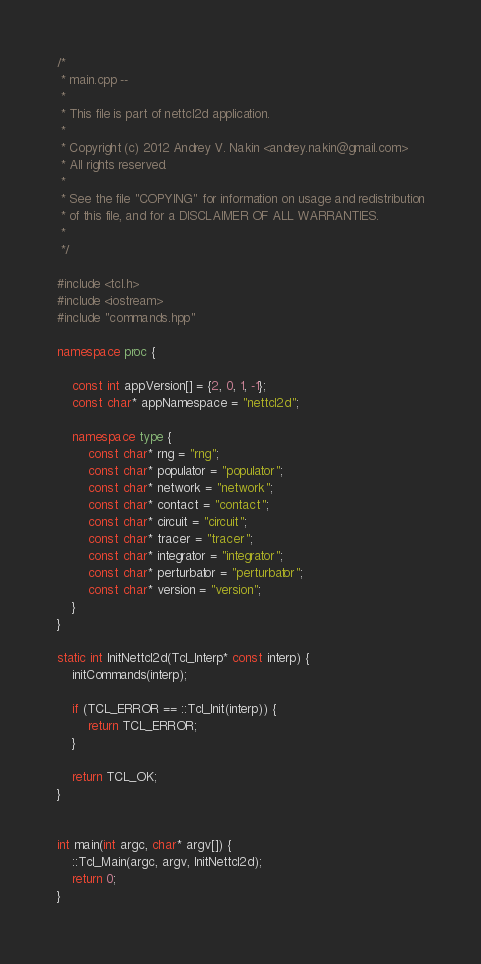Convert code to text. <code><loc_0><loc_0><loc_500><loc_500><_C++_>/*
 * main.cpp --
 *
 * This file is part of nettcl2d application.
 *
 * Copyright (c) 2012 Andrey V. Nakin <andrey.nakin@gmail.com>
 * All rights reserved.
 *
 * See the file "COPYING" for information on usage and redistribution
 * of this file, and for a DISCLAIMER OF ALL WARRANTIES.
 *
 */

#include <tcl.h>
#include <iostream>
#include "commands.hpp"

namespace proc {

	const int appVersion[] = {2, 0, 1, -1};
	const char* appNamespace = "nettcl2d";

	namespace type {
		const char* rng = "rng";
		const char* populator = "populator";
		const char* network = "network";
		const char* contact = "contact";
		const char* circuit = "circuit";
		const char* tracer = "tracer";
		const char* integrator = "integrator";
		const char* perturbator = "perturbator";
		const char* version = "version";
	}
}

static int InitNettcl2d(Tcl_Interp* const interp) {
	initCommands(interp);

	if (TCL_ERROR == ::Tcl_Init(interp)) {
		return TCL_ERROR;
	}

	return TCL_OK;
}


int main(int argc, char* argv[]) {
	::Tcl_Main(argc, argv, InitNettcl2d);
	return 0;
}
</code> 